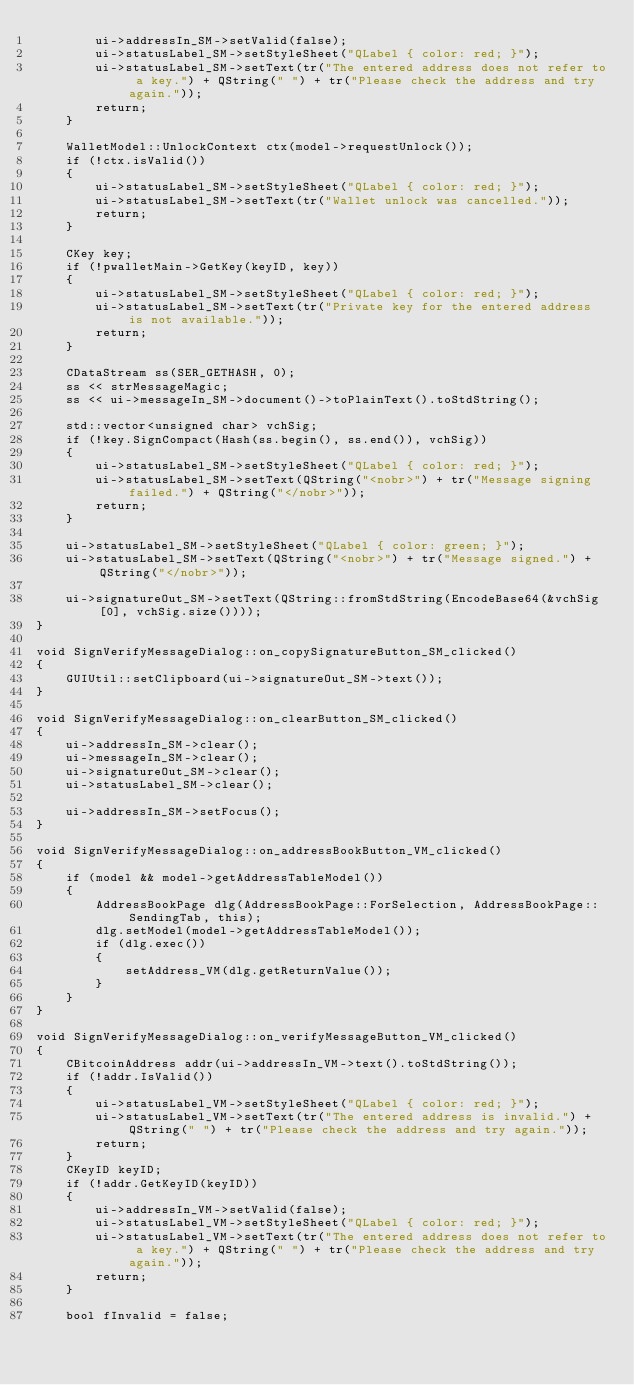Convert code to text. <code><loc_0><loc_0><loc_500><loc_500><_C++_>        ui->addressIn_SM->setValid(false);
        ui->statusLabel_SM->setStyleSheet("QLabel { color: red; }");
        ui->statusLabel_SM->setText(tr("The entered address does not refer to a key.") + QString(" ") + tr("Please check the address and try again."));
        return;
    }

    WalletModel::UnlockContext ctx(model->requestUnlock());
    if (!ctx.isValid())
    {
        ui->statusLabel_SM->setStyleSheet("QLabel { color: red; }");
        ui->statusLabel_SM->setText(tr("Wallet unlock was cancelled."));
        return;
    }

    CKey key;
    if (!pwalletMain->GetKey(keyID, key))
    {
        ui->statusLabel_SM->setStyleSheet("QLabel { color: red; }");
        ui->statusLabel_SM->setText(tr("Private key for the entered address is not available."));
        return;
    }

    CDataStream ss(SER_GETHASH, 0);
    ss << strMessageMagic;
    ss << ui->messageIn_SM->document()->toPlainText().toStdString();

    std::vector<unsigned char> vchSig;
    if (!key.SignCompact(Hash(ss.begin(), ss.end()), vchSig))
    {
        ui->statusLabel_SM->setStyleSheet("QLabel { color: red; }");
        ui->statusLabel_SM->setText(QString("<nobr>") + tr("Message signing failed.") + QString("</nobr>"));
        return;
    }

    ui->statusLabel_SM->setStyleSheet("QLabel { color: green; }");
    ui->statusLabel_SM->setText(QString("<nobr>") + tr("Message signed.") + QString("</nobr>"));

    ui->signatureOut_SM->setText(QString::fromStdString(EncodeBase64(&vchSig[0], vchSig.size())));
}

void SignVerifyMessageDialog::on_copySignatureButton_SM_clicked()
{
    GUIUtil::setClipboard(ui->signatureOut_SM->text());
}

void SignVerifyMessageDialog::on_clearButton_SM_clicked()
{
    ui->addressIn_SM->clear();
    ui->messageIn_SM->clear();
    ui->signatureOut_SM->clear();
    ui->statusLabel_SM->clear();

    ui->addressIn_SM->setFocus();
}

void SignVerifyMessageDialog::on_addressBookButton_VM_clicked()
{
    if (model && model->getAddressTableModel())
    {
        AddressBookPage dlg(AddressBookPage::ForSelection, AddressBookPage::SendingTab, this);
        dlg.setModel(model->getAddressTableModel());
        if (dlg.exec())
        {
            setAddress_VM(dlg.getReturnValue());
        }
    }
}

void SignVerifyMessageDialog::on_verifyMessageButton_VM_clicked()
{
    CBitcoinAddress addr(ui->addressIn_VM->text().toStdString());
    if (!addr.IsValid())
    {
        ui->statusLabel_VM->setStyleSheet("QLabel { color: red; }");
        ui->statusLabel_VM->setText(tr("The entered address is invalid.") + QString(" ") + tr("Please check the address and try again."));
        return;
    }
    CKeyID keyID;
    if (!addr.GetKeyID(keyID))
    {
        ui->addressIn_VM->setValid(false);
        ui->statusLabel_VM->setStyleSheet("QLabel { color: red; }");
        ui->statusLabel_VM->setText(tr("The entered address does not refer to a key.") + QString(" ") + tr("Please check the address and try again."));
        return;
    }

    bool fInvalid = false;</code> 